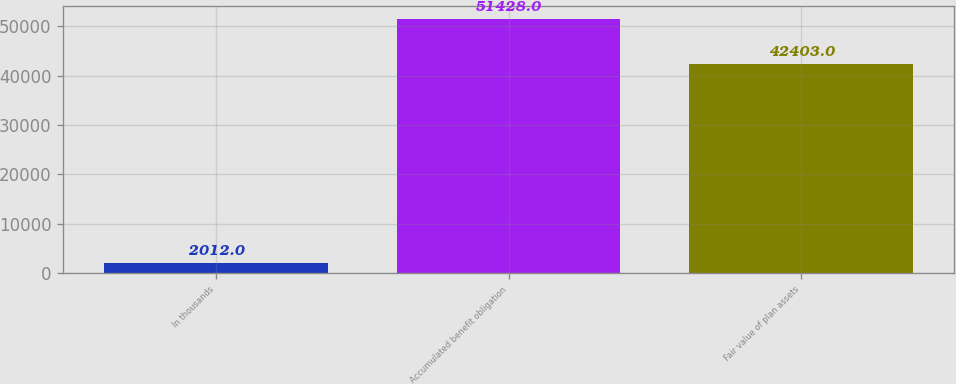Convert chart to OTSL. <chart><loc_0><loc_0><loc_500><loc_500><bar_chart><fcel>In thousands<fcel>Accumulated benefit obligation<fcel>Fair value of plan assets<nl><fcel>2012<fcel>51428<fcel>42403<nl></chart> 